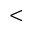Convert formula to latex. <formula><loc_0><loc_0><loc_500><loc_500><</formula> 